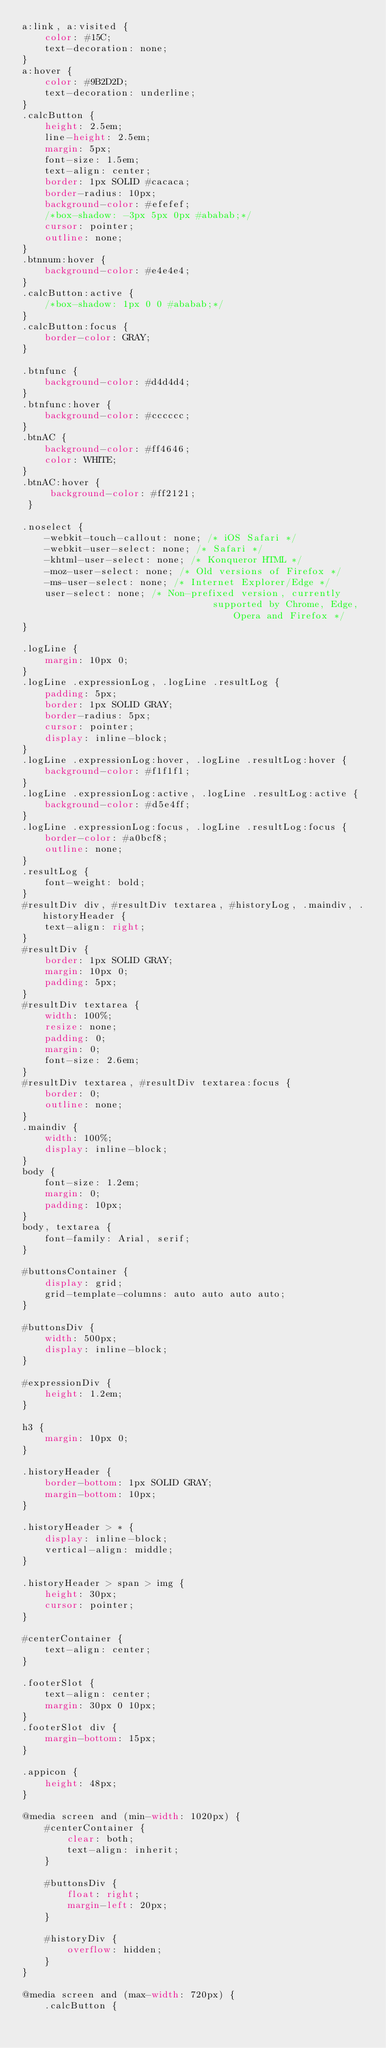<code> <loc_0><loc_0><loc_500><loc_500><_CSS_>a:link, a:visited {
    color: #15C;
    text-decoration: none;
}
a:hover {
    color: #9B2D2D;
    text-decoration: underline;
}
.calcButton {
    height: 2.5em;
    line-height: 2.5em;
    margin: 5px;
    font-size: 1.5em;
    text-align: center;
    border: 1px SOLID #cacaca;
    border-radius: 10px;
    background-color: #efefef;
    /*box-shadow: -3px 5px 0px #ababab;*/
    cursor: pointer;
    outline: none;
}
.btnnum:hover {
    background-color: #e4e4e4;
}
.calcButton:active {
    /*box-shadow: 1px 0 0 #ababab;*/
}
.calcButton:focus {
    border-color: GRAY;
}

.btnfunc {
    background-color: #d4d4d4;
}
.btnfunc:hover {
    background-color: #cccccc;
}
.btnAC {
    background-color: #ff4646;
    color: WHITE;
}
.btnAC:hover {
     background-color: #ff2121;
 }

.noselect {
    -webkit-touch-callout: none; /* iOS Safari */
    -webkit-user-select: none; /* Safari */
    -khtml-user-select: none; /* Konqueror HTML */
    -moz-user-select: none; /* Old versions of Firefox */
    -ms-user-select: none; /* Internet Explorer/Edge */
    user-select: none; /* Non-prefixed version, currently
                                  supported by Chrome, Edge, Opera and Firefox */
}

.logLine {
    margin: 10px 0;
}
.logLine .expressionLog, .logLine .resultLog {
    padding: 5px;
    border: 1px SOLID GRAY;
    border-radius: 5px;
    cursor: pointer;
    display: inline-block;
}
.logLine .expressionLog:hover, .logLine .resultLog:hover {
    background-color: #f1f1f1;
}
.logLine .expressionLog:active, .logLine .resultLog:active {
    background-color: #d5e4ff;
}
.logLine .expressionLog:focus, .logLine .resultLog:focus {
    border-color: #a0bcf8;
    outline: none;
}
.resultLog {
    font-weight: bold;
}
#resultDiv div, #resultDiv textarea, #historyLog, .maindiv, .historyHeader {
    text-align: right;
}
#resultDiv {
    border: 1px SOLID GRAY;
    margin: 10px 0;
    padding: 5px;
}
#resultDiv textarea {
    width: 100%;
    resize: none;
    padding: 0;
    margin: 0;
    font-size: 2.6em;
}
#resultDiv textarea, #resultDiv textarea:focus {
    border: 0;
    outline: none;
}
.maindiv {
    width: 100%;
    display: inline-block;
}
body {
    font-size: 1.2em;
    margin: 0;
    padding: 10px;
}
body, textarea {
    font-family: Arial, serif;
}

#buttonsContainer {
    display: grid;
    grid-template-columns: auto auto auto auto;
}

#buttonsDiv {
    width: 500px;
    display: inline-block;
}

#expressionDiv {
    height: 1.2em;
}

h3 {
    margin: 10px 0;
}

.historyHeader {
    border-bottom: 1px SOLID GRAY;
    margin-bottom: 10px;
}

.historyHeader > * {
    display: inline-block;
    vertical-align: middle;
}

.historyHeader > span > img {
    height: 30px;
    cursor: pointer;
}

#centerContainer {
    text-align: center;
}

.footerSlot {
    text-align: center;
    margin: 30px 0 10px;
}
.footerSlot div {
    margin-bottom: 15px;
}

.appicon {
    height: 48px;
}

@media screen and (min-width: 1020px) {
    #centerContainer {
        clear: both;
        text-align: inherit;
    }

    #buttonsDiv {
        float: right;
        margin-left: 20px;
    }

    #historyDiv {
        overflow: hidden;
    }
}

@media screen and (max-width: 720px) {
    .calcButton {</code> 